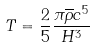Convert formula to latex. <formula><loc_0><loc_0><loc_500><loc_500>T = \frac { 2 } { 5 } \frac { \pi \overline { \rho } c ^ { 5 } } { H ^ { 3 } }</formula> 